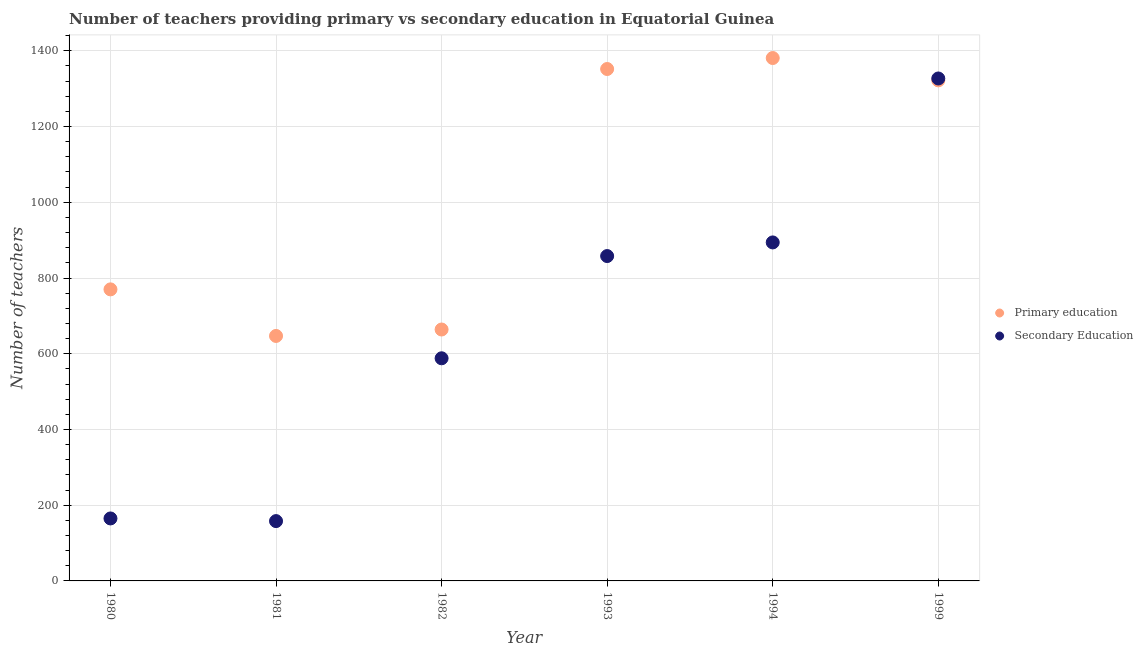How many different coloured dotlines are there?
Offer a terse response. 2. What is the number of primary teachers in 1980?
Make the answer very short. 770. Across all years, what is the maximum number of primary teachers?
Keep it short and to the point. 1381. Across all years, what is the minimum number of primary teachers?
Your response must be concise. 647. In which year was the number of secondary teachers minimum?
Your answer should be very brief. 1981. What is the total number of primary teachers in the graph?
Give a very brief answer. 6136. What is the difference between the number of primary teachers in 1982 and that in 1993?
Your answer should be very brief. -688. What is the difference between the number of secondary teachers in 1980 and the number of primary teachers in 1993?
Ensure brevity in your answer.  -1187. What is the average number of primary teachers per year?
Give a very brief answer. 1022.67. In the year 1982, what is the difference between the number of primary teachers and number of secondary teachers?
Offer a terse response. 76. What is the ratio of the number of secondary teachers in 1982 to that in 1993?
Your answer should be compact. 0.69. Is the number of secondary teachers in 1980 less than that in 1982?
Offer a very short reply. Yes. Is the difference between the number of secondary teachers in 1982 and 1993 greater than the difference between the number of primary teachers in 1982 and 1993?
Provide a short and direct response. Yes. What is the difference between the highest and the second highest number of primary teachers?
Make the answer very short. 29. What is the difference between the highest and the lowest number of primary teachers?
Your response must be concise. 734. Does the number of primary teachers monotonically increase over the years?
Your answer should be compact. No. Is the number of primary teachers strictly greater than the number of secondary teachers over the years?
Offer a very short reply. No. How many years are there in the graph?
Offer a terse response. 6. Does the graph contain any zero values?
Give a very brief answer. No. Does the graph contain grids?
Your answer should be very brief. Yes. How many legend labels are there?
Ensure brevity in your answer.  2. What is the title of the graph?
Keep it short and to the point. Number of teachers providing primary vs secondary education in Equatorial Guinea. What is the label or title of the X-axis?
Offer a very short reply. Year. What is the label or title of the Y-axis?
Your answer should be compact. Number of teachers. What is the Number of teachers in Primary education in 1980?
Offer a very short reply. 770. What is the Number of teachers in Secondary Education in 1980?
Keep it short and to the point. 165. What is the Number of teachers in Primary education in 1981?
Your answer should be very brief. 647. What is the Number of teachers of Secondary Education in 1981?
Your answer should be very brief. 158. What is the Number of teachers of Primary education in 1982?
Your answer should be compact. 664. What is the Number of teachers in Secondary Education in 1982?
Your response must be concise. 588. What is the Number of teachers in Primary education in 1993?
Your answer should be very brief. 1352. What is the Number of teachers of Secondary Education in 1993?
Your response must be concise. 858. What is the Number of teachers in Primary education in 1994?
Ensure brevity in your answer.  1381. What is the Number of teachers of Secondary Education in 1994?
Your answer should be very brief. 894. What is the Number of teachers of Primary education in 1999?
Provide a short and direct response. 1322. What is the Number of teachers of Secondary Education in 1999?
Offer a terse response. 1327. Across all years, what is the maximum Number of teachers in Primary education?
Your answer should be very brief. 1381. Across all years, what is the maximum Number of teachers in Secondary Education?
Provide a succinct answer. 1327. Across all years, what is the minimum Number of teachers in Primary education?
Give a very brief answer. 647. Across all years, what is the minimum Number of teachers in Secondary Education?
Provide a succinct answer. 158. What is the total Number of teachers in Primary education in the graph?
Provide a short and direct response. 6136. What is the total Number of teachers in Secondary Education in the graph?
Offer a very short reply. 3990. What is the difference between the Number of teachers of Primary education in 1980 and that in 1981?
Provide a succinct answer. 123. What is the difference between the Number of teachers in Primary education in 1980 and that in 1982?
Keep it short and to the point. 106. What is the difference between the Number of teachers of Secondary Education in 1980 and that in 1982?
Offer a terse response. -423. What is the difference between the Number of teachers in Primary education in 1980 and that in 1993?
Give a very brief answer. -582. What is the difference between the Number of teachers of Secondary Education in 1980 and that in 1993?
Provide a succinct answer. -693. What is the difference between the Number of teachers of Primary education in 1980 and that in 1994?
Provide a succinct answer. -611. What is the difference between the Number of teachers in Secondary Education in 1980 and that in 1994?
Your answer should be compact. -729. What is the difference between the Number of teachers in Primary education in 1980 and that in 1999?
Provide a short and direct response. -552. What is the difference between the Number of teachers of Secondary Education in 1980 and that in 1999?
Offer a very short reply. -1162. What is the difference between the Number of teachers in Primary education in 1981 and that in 1982?
Your response must be concise. -17. What is the difference between the Number of teachers of Secondary Education in 1981 and that in 1982?
Provide a succinct answer. -430. What is the difference between the Number of teachers in Primary education in 1981 and that in 1993?
Provide a succinct answer. -705. What is the difference between the Number of teachers of Secondary Education in 1981 and that in 1993?
Your response must be concise. -700. What is the difference between the Number of teachers of Primary education in 1981 and that in 1994?
Provide a succinct answer. -734. What is the difference between the Number of teachers of Secondary Education in 1981 and that in 1994?
Your answer should be compact. -736. What is the difference between the Number of teachers in Primary education in 1981 and that in 1999?
Your answer should be compact. -675. What is the difference between the Number of teachers in Secondary Education in 1981 and that in 1999?
Offer a terse response. -1169. What is the difference between the Number of teachers in Primary education in 1982 and that in 1993?
Provide a succinct answer. -688. What is the difference between the Number of teachers in Secondary Education in 1982 and that in 1993?
Offer a terse response. -270. What is the difference between the Number of teachers of Primary education in 1982 and that in 1994?
Provide a succinct answer. -717. What is the difference between the Number of teachers of Secondary Education in 1982 and that in 1994?
Your answer should be very brief. -306. What is the difference between the Number of teachers in Primary education in 1982 and that in 1999?
Give a very brief answer. -658. What is the difference between the Number of teachers in Secondary Education in 1982 and that in 1999?
Give a very brief answer. -739. What is the difference between the Number of teachers in Primary education in 1993 and that in 1994?
Provide a short and direct response. -29. What is the difference between the Number of teachers in Secondary Education in 1993 and that in 1994?
Your response must be concise. -36. What is the difference between the Number of teachers of Secondary Education in 1993 and that in 1999?
Offer a very short reply. -469. What is the difference between the Number of teachers of Secondary Education in 1994 and that in 1999?
Provide a short and direct response. -433. What is the difference between the Number of teachers in Primary education in 1980 and the Number of teachers in Secondary Education in 1981?
Keep it short and to the point. 612. What is the difference between the Number of teachers in Primary education in 1980 and the Number of teachers in Secondary Education in 1982?
Keep it short and to the point. 182. What is the difference between the Number of teachers of Primary education in 1980 and the Number of teachers of Secondary Education in 1993?
Ensure brevity in your answer.  -88. What is the difference between the Number of teachers of Primary education in 1980 and the Number of teachers of Secondary Education in 1994?
Ensure brevity in your answer.  -124. What is the difference between the Number of teachers in Primary education in 1980 and the Number of teachers in Secondary Education in 1999?
Your answer should be very brief. -557. What is the difference between the Number of teachers in Primary education in 1981 and the Number of teachers in Secondary Education in 1993?
Offer a terse response. -211. What is the difference between the Number of teachers of Primary education in 1981 and the Number of teachers of Secondary Education in 1994?
Give a very brief answer. -247. What is the difference between the Number of teachers in Primary education in 1981 and the Number of teachers in Secondary Education in 1999?
Your answer should be compact. -680. What is the difference between the Number of teachers of Primary education in 1982 and the Number of teachers of Secondary Education in 1993?
Provide a succinct answer. -194. What is the difference between the Number of teachers in Primary education in 1982 and the Number of teachers in Secondary Education in 1994?
Offer a terse response. -230. What is the difference between the Number of teachers in Primary education in 1982 and the Number of teachers in Secondary Education in 1999?
Give a very brief answer. -663. What is the difference between the Number of teachers of Primary education in 1993 and the Number of teachers of Secondary Education in 1994?
Provide a short and direct response. 458. What is the difference between the Number of teachers of Primary education in 1993 and the Number of teachers of Secondary Education in 1999?
Make the answer very short. 25. What is the difference between the Number of teachers of Primary education in 1994 and the Number of teachers of Secondary Education in 1999?
Ensure brevity in your answer.  54. What is the average Number of teachers in Primary education per year?
Provide a short and direct response. 1022.67. What is the average Number of teachers in Secondary Education per year?
Your response must be concise. 665. In the year 1980, what is the difference between the Number of teachers in Primary education and Number of teachers in Secondary Education?
Make the answer very short. 605. In the year 1981, what is the difference between the Number of teachers of Primary education and Number of teachers of Secondary Education?
Keep it short and to the point. 489. In the year 1982, what is the difference between the Number of teachers of Primary education and Number of teachers of Secondary Education?
Make the answer very short. 76. In the year 1993, what is the difference between the Number of teachers in Primary education and Number of teachers in Secondary Education?
Provide a succinct answer. 494. In the year 1994, what is the difference between the Number of teachers in Primary education and Number of teachers in Secondary Education?
Keep it short and to the point. 487. What is the ratio of the Number of teachers in Primary education in 1980 to that in 1981?
Your answer should be compact. 1.19. What is the ratio of the Number of teachers of Secondary Education in 1980 to that in 1981?
Offer a very short reply. 1.04. What is the ratio of the Number of teachers of Primary education in 1980 to that in 1982?
Keep it short and to the point. 1.16. What is the ratio of the Number of teachers in Secondary Education in 1980 to that in 1982?
Ensure brevity in your answer.  0.28. What is the ratio of the Number of teachers in Primary education in 1980 to that in 1993?
Make the answer very short. 0.57. What is the ratio of the Number of teachers in Secondary Education in 1980 to that in 1993?
Provide a short and direct response. 0.19. What is the ratio of the Number of teachers in Primary education in 1980 to that in 1994?
Offer a terse response. 0.56. What is the ratio of the Number of teachers of Secondary Education in 1980 to that in 1994?
Offer a terse response. 0.18. What is the ratio of the Number of teachers in Primary education in 1980 to that in 1999?
Keep it short and to the point. 0.58. What is the ratio of the Number of teachers in Secondary Education in 1980 to that in 1999?
Ensure brevity in your answer.  0.12. What is the ratio of the Number of teachers in Primary education in 1981 to that in 1982?
Keep it short and to the point. 0.97. What is the ratio of the Number of teachers of Secondary Education in 1981 to that in 1982?
Offer a very short reply. 0.27. What is the ratio of the Number of teachers of Primary education in 1981 to that in 1993?
Your answer should be very brief. 0.48. What is the ratio of the Number of teachers of Secondary Education in 1981 to that in 1993?
Your response must be concise. 0.18. What is the ratio of the Number of teachers in Primary education in 1981 to that in 1994?
Give a very brief answer. 0.47. What is the ratio of the Number of teachers in Secondary Education in 1981 to that in 1994?
Provide a short and direct response. 0.18. What is the ratio of the Number of teachers in Primary education in 1981 to that in 1999?
Your answer should be compact. 0.49. What is the ratio of the Number of teachers in Secondary Education in 1981 to that in 1999?
Offer a very short reply. 0.12. What is the ratio of the Number of teachers of Primary education in 1982 to that in 1993?
Your response must be concise. 0.49. What is the ratio of the Number of teachers of Secondary Education in 1982 to that in 1993?
Give a very brief answer. 0.69. What is the ratio of the Number of teachers of Primary education in 1982 to that in 1994?
Offer a very short reply. 0.48. What is the ratio of the Number of teachers in Secondary Education in 1982 to that in 1994?
Keep it short and to the point. 0.66. What is the ratio of the Number of teachers of Primary education in 1982 to that in 1999?
Ensure brevity in your answer.  0.5. What is the ratio of the Number of teachers of Secondary Education in 1982 to that in 1999?
Your response must be concise. 0.44. What is the ratio of the Number of teachers in Secondary Education in 1993 to that in 1994?
Your answer should be compact. 0.96. What is the ratio of the Number of teachers in Primary education in 1993 to that in 1999?
Ensure brevity in your answer.  1.02. What is the ratio of the Number of teachers of Secondary Education in 1993 to that in 1999?
Keep it short and to the point. 0.65. What is the ratio of the Number of teachers in Primary education in 1994 to that in 1999?
Your answer should be very brief. 1.04. What is the ratio of the Number of teachers in Secondary Education in 1994 to that in 1999?
Give a very brief answer. 0.67. What is the difference between the highest and the second highest Number of teachers of Primary education?
Ensure brevity in your answer.  29. What is the difference between the highest and the second highest Number of teachers of Secondary Education?
Your response must be concise. 433. What is the difference between the highest and the lowest Number of teachers of Primary education?
Provide a short and direct response. 734. What is the difference between the highest and the lowest Number of teachers of Secondary Education?
Your answer should be compact. 1169. 